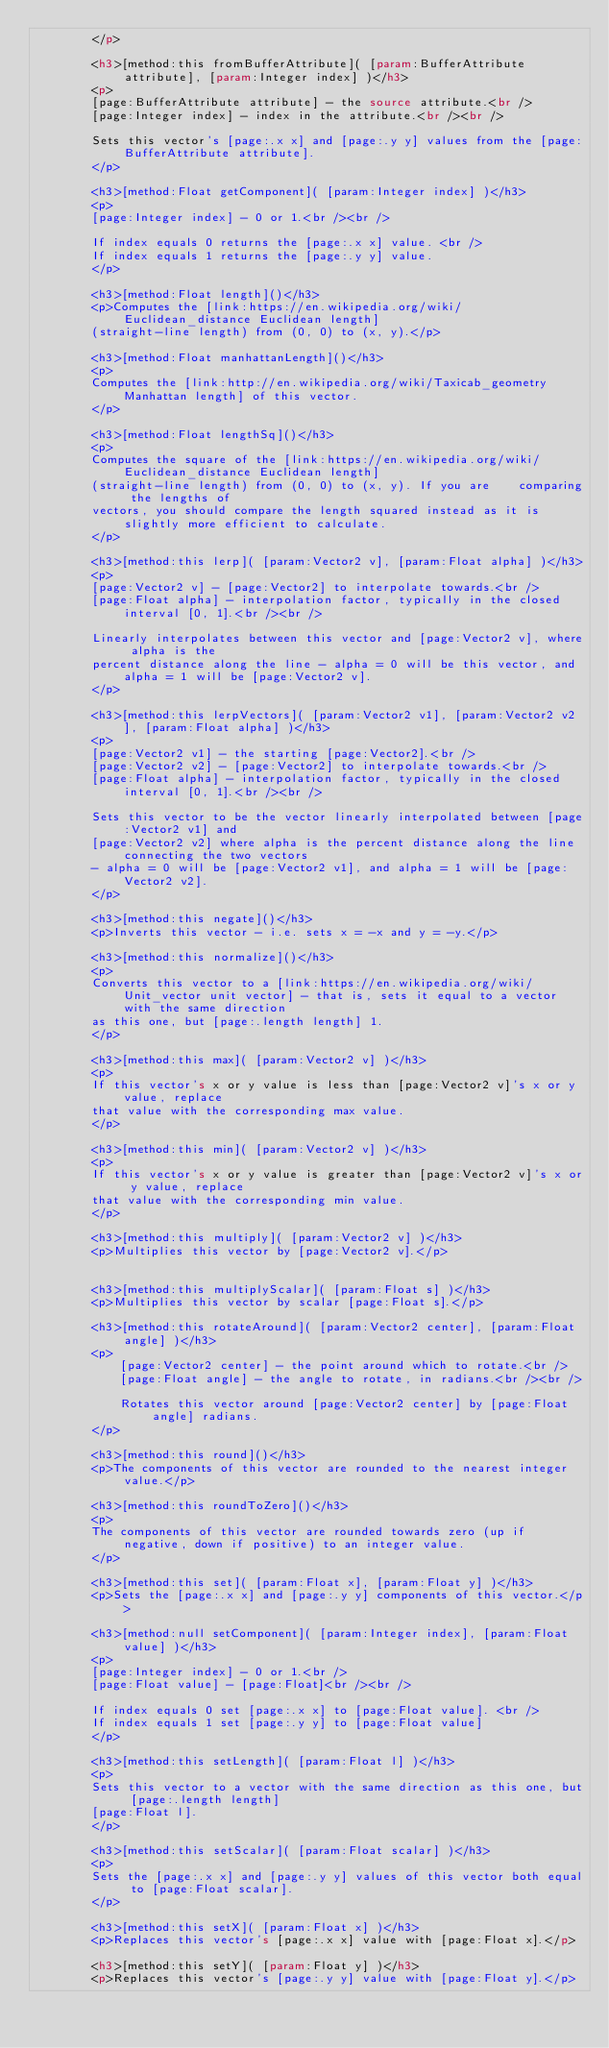Convert code to text. <code><loc_0><loc_0><loc_500><loc_500><_HTML_>		</p>

		<h3>[method:this fromBufferAttribute]( [param:BufferAttribute attribute], [param:Integer index] )</h3>
		<p>
		[page:BufferAttribute attribute] - the source attribute.<br />
		[page:Integer index] - index in the attribute.<br /><br />

		Sets this vector's [page:.x x] and [page:.y y] values from the [page:BufferAttribute attribute].
		</p>

		<h3>[method:Float getComponent]( [param:Integer index] )</h3>
		<p>
		[page:Integer index] - 0 or 1.<br /><br />

		If index equals 0 returns the [page:.x x] value. <br />
		If index equals 1 returns the [page:.y y] value.
		</p>

		<h3>[method:Float length]()</h3>
		<p>Computes the [link:https://en.wikipedia.org/wiki/Euclidean_distance Euclidean length]
		(straight-line length) from (0, 0) to (x, y).</p>

		<h3>[method:Float manhattanLength]()</h3>
		<p>
		Computes the [link:http://en.wikipedia.org/wiki/Taxicab_geometry Manhattan length] of this vector.
		</p>

		<h3>[method:Float lengthSq]()</h3>
		<p>
		Computes the square of the [link:https://en.wikipedia.org/wiki/Euclidean_distance Euclidean length]
		(straight-line length) from (0, 0) to (x, y). If you are 	comparing the lengths of
		vectors, you should compare the length squared instead as it is slightly more efficient to calculate.
		</p>

		<h3>[method:this lerp]( [param:Vector2 v], [param:Float alpha] )</h3>
		<p>
		[page:Vector2 v] - [page:Vector2] to interpolate towards.<br />
		[page:Float alpha] - interpolation factor, typically in the closed interval [0, 1].<br /><br />

		Linearly interpolates between this vector and [page:Vector2 v], where alpha is the
		percent distance along the line - alpha = 0 will be this vector, and alpha = 1 will be [page:Vector2 v].
		</p>

		<h3>[method:this lerpVectors]( [param:Vector2 v1], [param:Vector2 v2], [param:Float alpha] )</h3>
		<p>
		[page:Vector2 v1] - the starting [page:Vector2].<br />
		[page:Vector2 v2] - [page:Vector2] to interpolate towards.<br />
		[page:Float alpha] - interpolation factor, typically in the closed interval [0, 1].<br /><br />

		Sets this vector to be the vector linearly interpolated between [page:Vector2 v1] and
		[page:Vector2 v2] where alpha is the percent distance along the line connecting the two vectors
		- alpha = 0 will be [page:Vector2 v1], and alpha = 1 will be [page:Vector2 v2].
		</p>

		<h3>[method:this negate]()</h3>
		<p>Inverts this vector - i.e. sets x = -x and y = -y.</p>

		<h3>[method:this normalize]()</h3>
		<p>
		Converts this vector to a [link:https://en.wikipedia.org/wiki/Unit_vector unit vector] - that is, sets it equal to a vector with the same direction
		as this one, but [page:.length length] 1.
		</p>

		<h3>[method:this max]( [param:Vector2 v] )</h3>
		<p>
		If this vector's x or y value is less than [page:Vector2 v]'s x or y value, replace
		that value with the corresponding max value.
		</p>

		<h3>[method:this min]( [param:Vector2 v] )</h3>
		<p>
		If this vector's x or y value is greater than [page:Vector2 v]'s x or y value, replace
		that value with the corresponding min value.
		</p>

		<h3>[method:this multiply]( [param:Vector2 v] )</h3>
		<p>Multiplies this vector by [page:Vector2 v].</p>


		<h3>[method:this multiplyScalar]( [param:Float s] )</h3>
		<p>Multiplies this vector by scalar [page:Float s].</p>

		<h3>[method:this rotateAround]( [param:Vector2 center], [param:Float angle] )</h3>
		<p>
			[page:Vector2 center] - the point around which to rotate.<br />
			[page:Float angle] - the angle to rotate, in radians.<br /><br />

			Rotates this vector around [page:Vector2 center] by [page:Float angle] radians.
		</p>

		<h3>[method:this round]()</h3>
		<p>The components of this vector are rounded to the nearest integer value.</p>

		<h3>[method:this roundToZero]()</h3>
		<p>
		The components of this vector are rounded towards zero (up if negative, down if positive) to an integer value.
		</p>

		<h3>[method:this set]( [param:Float x], [param:Float y] )</h3>
		<p>Sets the [page:.x x] and [page:.y y] components of this vector.</p>

		<h3>[method:null setComponent]( [param:Integer index], [param:Float value] )</h3>
		<p>
		[page:Integer index] - 0 or 1.<br />
		[page:Float value] - [page:Float]<br /><br />

		If index equals 0 set [page:.x x] to [page:Float value]. <br />
		If index equals 1 set [page:.y y] to [page:Float value]
		</p>

		<h3>[method:this setLength]( [param:Float l] )</h3>
		<p>
		Sets this vector to a vector with the same direction as this one, but [page:.length length]
		[page:Float l].
		</p>

		<h3>[method:this setScalar]( [param:Float scalar] )</h3>
		<p>
		Sets the [page:.x x] and [page:.y y] values of this vector both equal to [page:Float scalar].
		</p>

		<h3>[method:this setX]( [param:Float x] )</h3>
		<p>Replaces this vector's [page:.x x] value with [page:Float x].</p>

		<h3>[method:this setY]( [param:Float y] )</h3>
		<p>Replaces this vector's [page:.y y] value with [page:Float y].</p>
</code> 